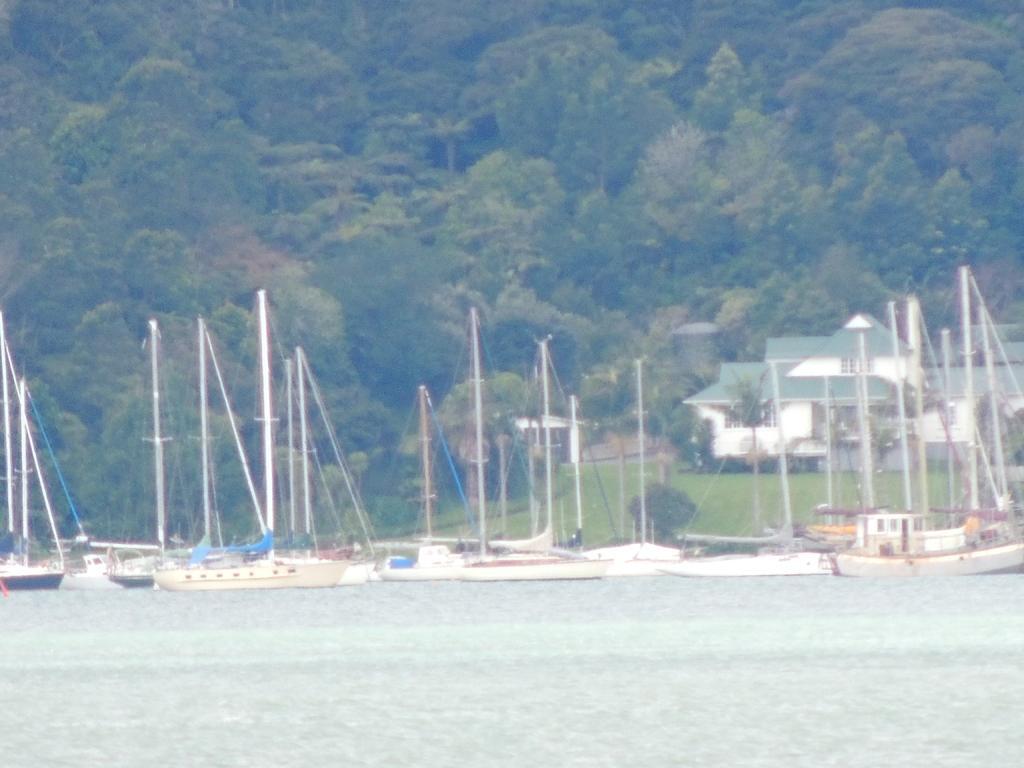Please provide a concise description of this image. In this image, in the middle there are boats, water, grass, plants, trees, house. 